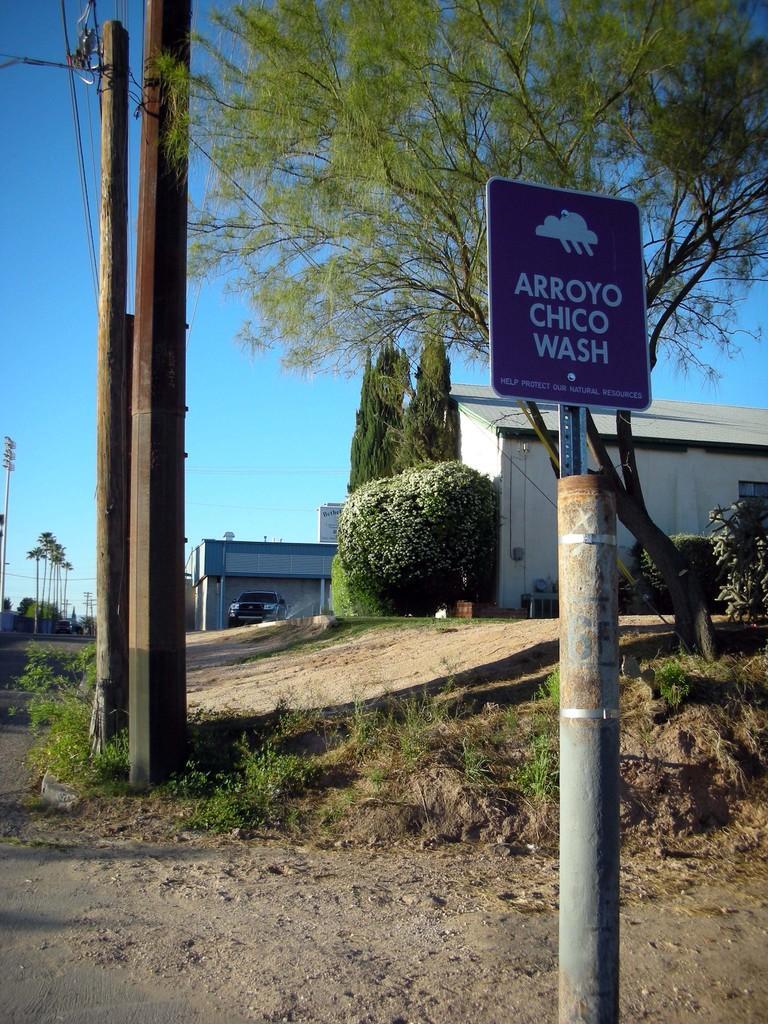In one or two sentences, can you explain what this image depicts? This is an outside view. Here I can see few poles on the ground and there are some plants. In the background there are few buildings and trees and also I can see a car. On the right side there is a board attached to a pole. On the board, I can see some text. At the top of the image I can see the sky. 